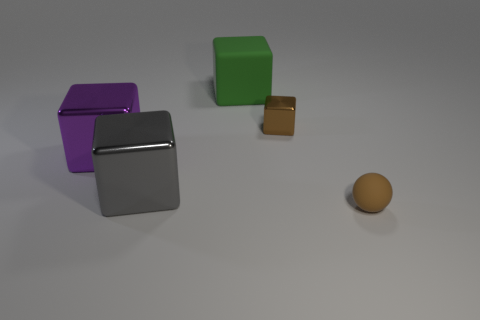Add 1 large shiny things. How many objects exist? 6 Subtract all balls. How many objects are left? 4 Add 4 purple things. How many purple things are left? 5 Add 1 tiny brown matte objects. How many tiny brown matte objects exist? 2 Subtract 0 cyan spheres. How many objects are left? 5 Subtract all purple matte blocks. Subtract all small matte objects. How many objects are left? 4 